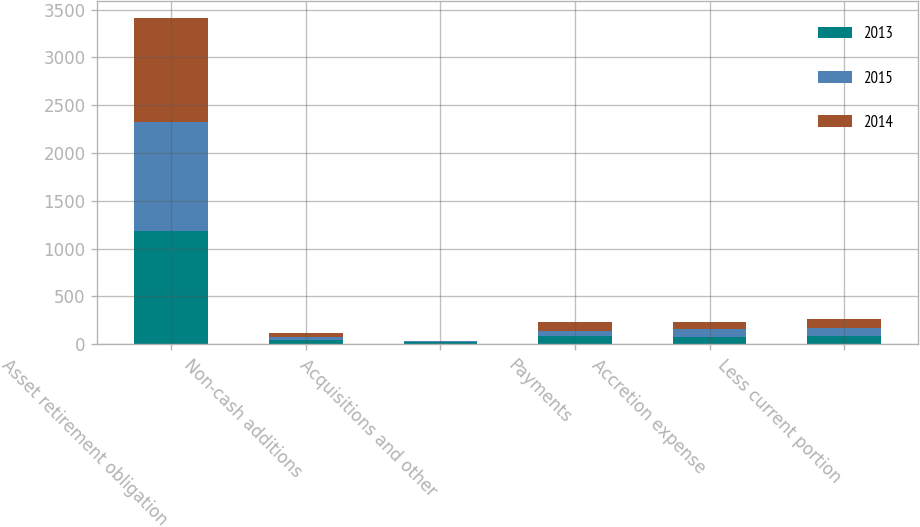<chart> <loc_0><loc_0><loc_500><loc_500><stacked_bar_chart><ecel><fcel>Asset retirement obligation<fcel>Non-cash additions<fcel>Acquisitions and other<fcel>Payments<fcel>Accretion expense<fcel>Less current portion<nl><fcel>2013<fcel>1181.6<fcel>39.4<fcel>27.1<fcel>88.4<fcel>79.4<fcel>87.4<nl><fcel>2015<fcel>1144.3<fcel>38.6<fcel>3.8<fcel>54.6<fcel>78<fcel>87.9<nl><fcel>2014<fcel>1091.3<fcel>36.5<fcel>0.6<fcel>85.6<fcel>76.6<fcel>93.6<nl></chart> 